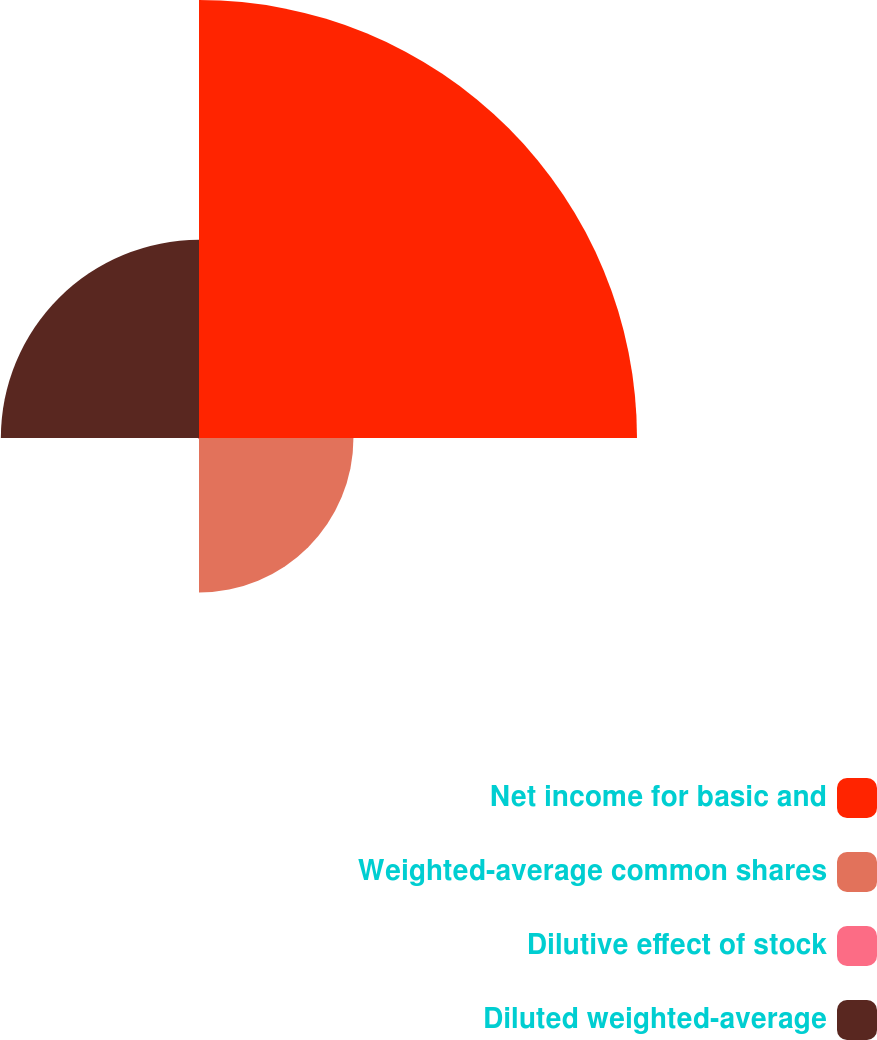Convert chart to OTSL. <chart><loc_0><loc_0><loc_500><loc_500><pie_chart><fcel>Net income for basic and<fcel>Weighted-average common shares<fcel>Dilutive effect of stock<fcel>Diluted weighted-average<nl><fcel>55.33%<fcel>19.51%<fcel>0.13%<fcel>25.03%<nl></chart> 